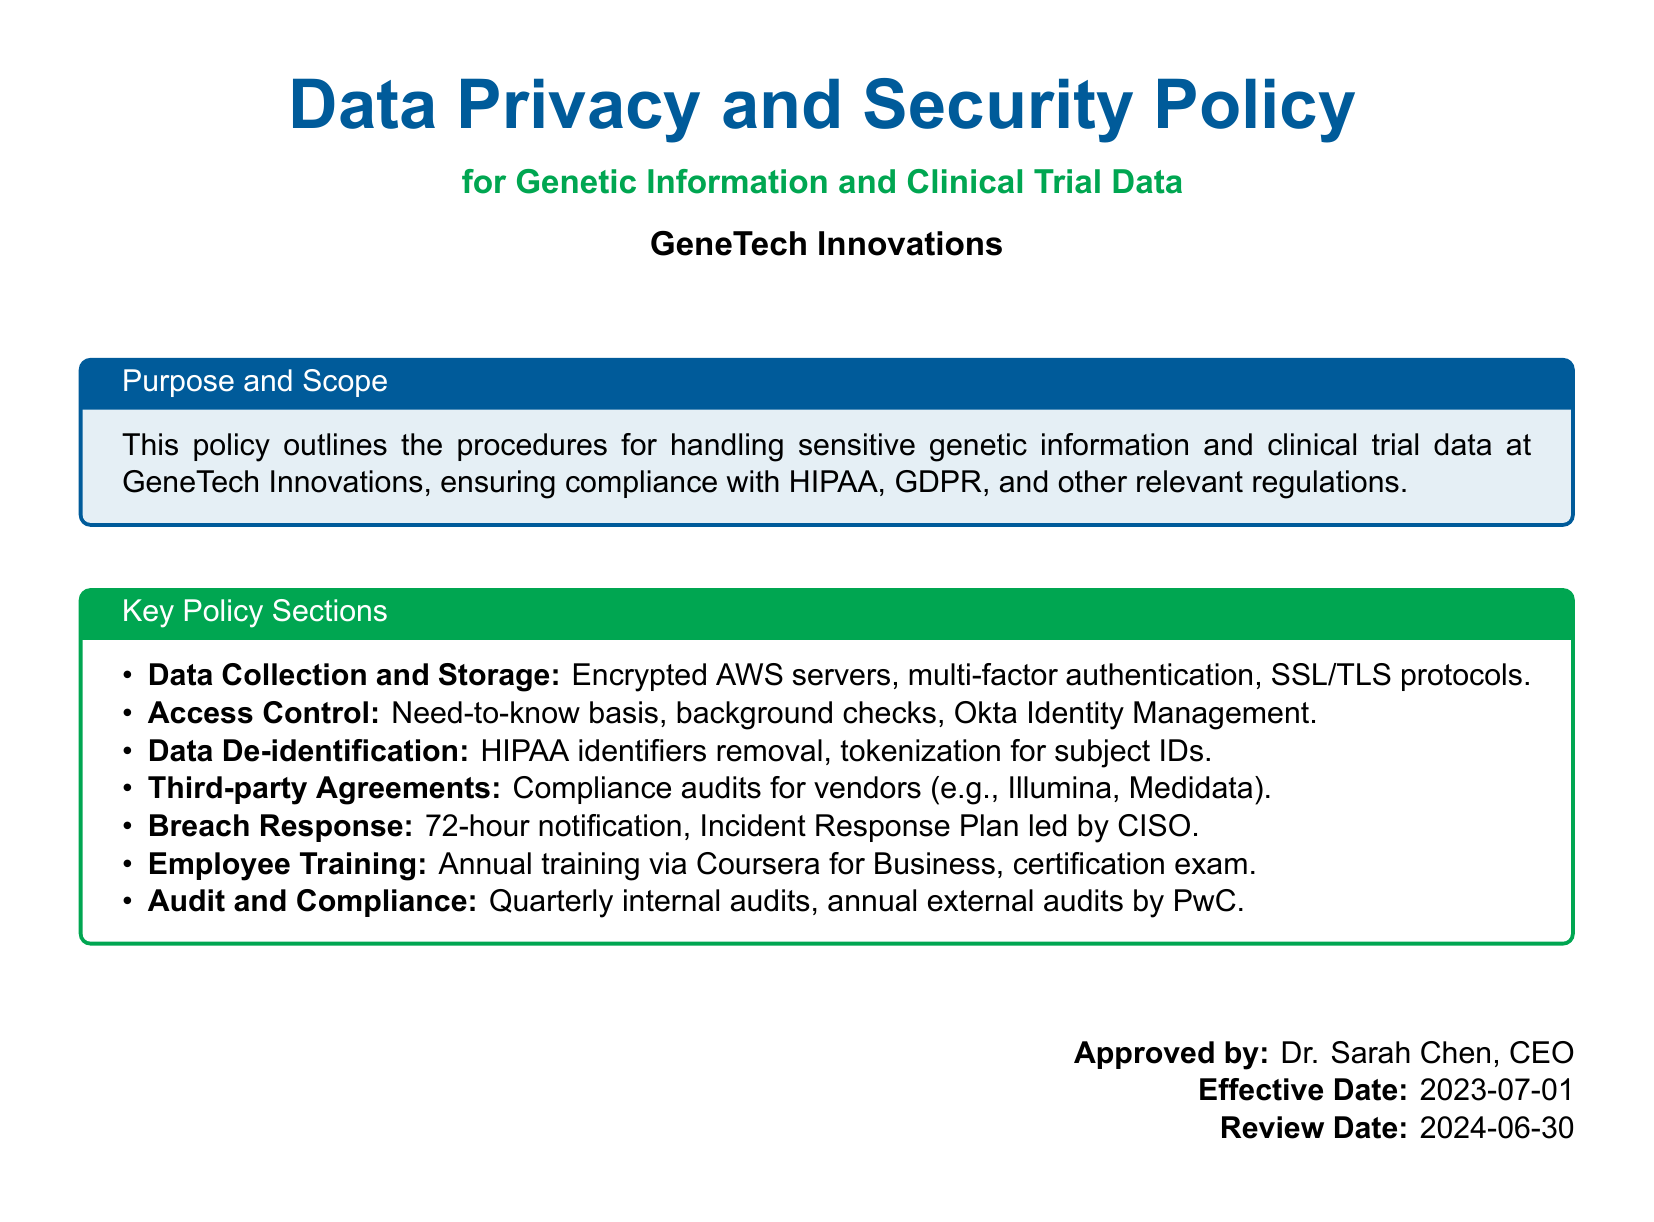What are the compliance regulations mentioned? The compliance regulations mentioned in the document are HIPAA, GDPR, and other relevant regulations.
Answer: HIPAA, GDPR Who approved the policy? The document lists Dr. Sarah Chen as the approver of the policy.
Answer: Dr. Sarah Chen What is the effective date of the policy? The effective date is specified in the document as the date it came into effect.
Answer: 2023-07-01 What type of training is provided to employees? The document indicates the type of training provided to employees related to data privacy and security.
Answer: Annual training via Coursera for Business What is the response time for a data breach notification? The document outlines a specific time frame for notification in case of a data breach.
Answer: 72-hour notification How often are internal audits conducted? The document specifies the frequency of internal audits as part of the compliance procedures.
Answer: Quarterly internal audits What encryption method is used for data storage? The policy outlines the encryption methods utilized for storing sensitive data.
Answer: Encrypted AWS servers What tokenization is mentioned for subject identifiers? The document refers to a specific method for handling subject identifiers while maintaining privacy.
Answer: Tokenization for subject IDs What kind of access control is implemented? The document describes the access control strategy based on specific criteria.
Answer: Need-to-know basis 